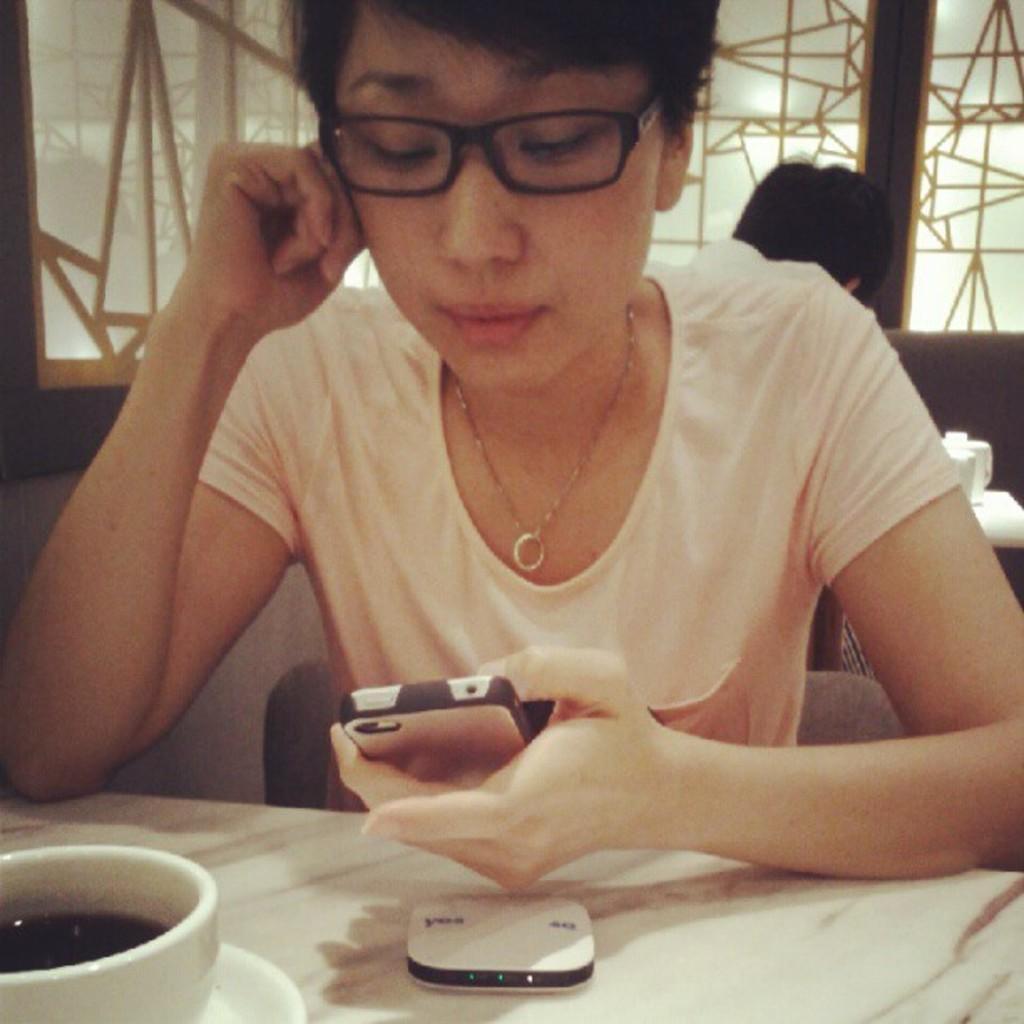How would you summarize this image in a sentence or two? In this picture there is a woman who is wearing spectacle, locket and t-shirt. She is looking on the phone. On the table I can see the tea cup, saucer and router. Behind her there is another person who is sitting on the couch. In the top right I can see the window glass partition. 